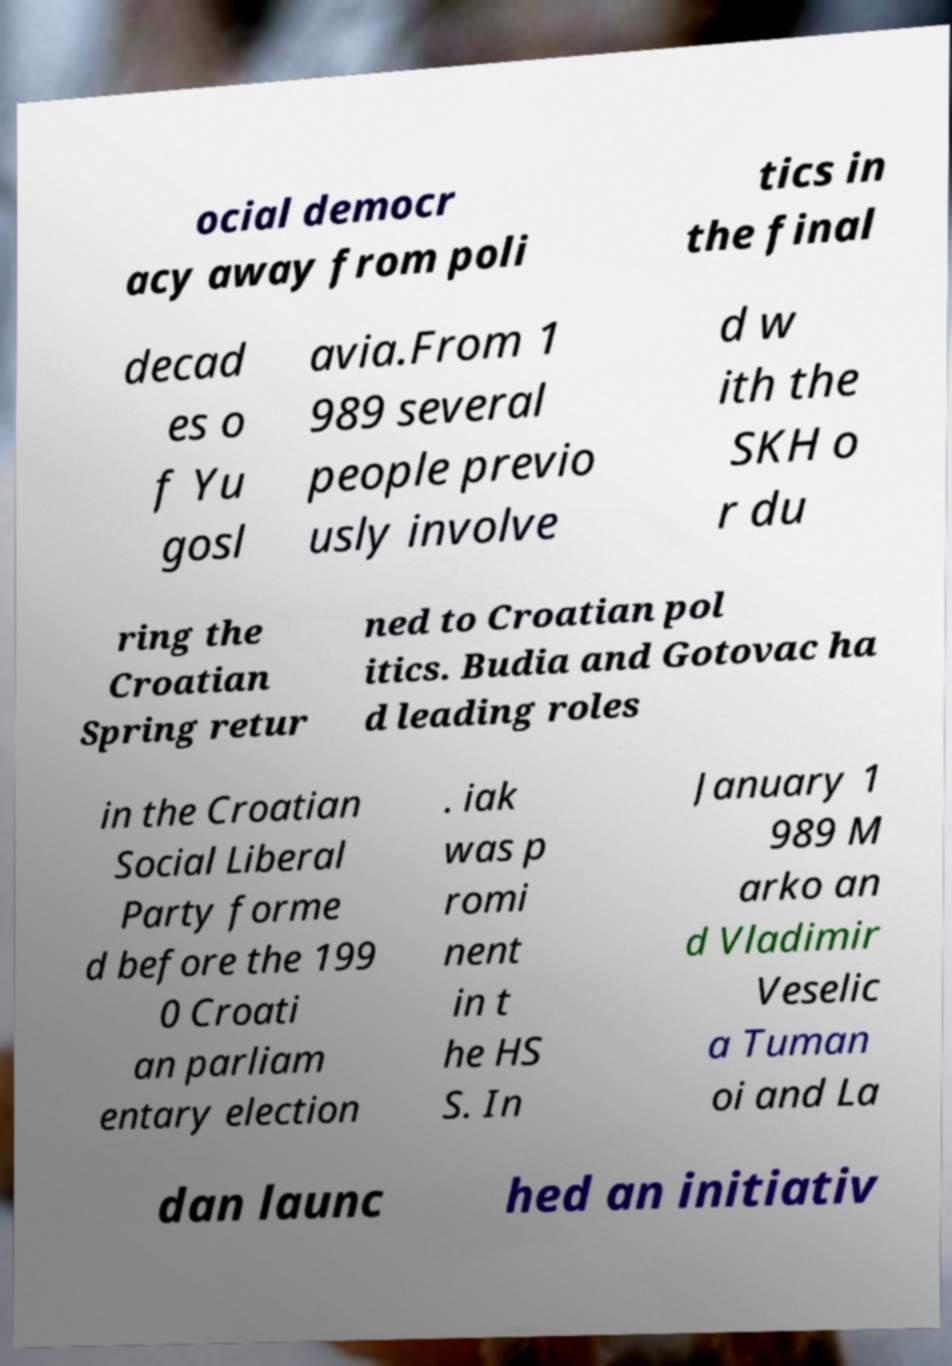Can you read and provide the text displayed in the image?This photo seems to have some interesting text. Can you extract and type it out for me? ocial democr acy away from poli tics in the final decad es o f Yu gosl avia.From 1 989 several people previo usly involve d w ith the SKH o r du ring the Croatian Spring retur ned to Croatian pol itics. Budia and Gotovac ha d leading roles in the Croatian Social Liberal Party forme d before the 199 0 Croati an parliam entary election . iak was p romi nent in t he HS S. In January 1 989 M arko an d Vladimir Veselic a Tuman oi and La dan launc hed an initiativ 